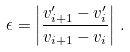Convert formula to latex. <formula><loc_0><loc_0><loc_500><loc_500>\epsilon = \left | \frac { v _ { i + 1 } ^ { \prime } - v _ { i } ^ { \prime } } { v _ { i + 1 } - v _ { i } } \right | \, .</formula> 